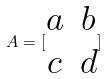Convert formula to latex. <formula><loc_0><loc_0><loc_500><loc_500>A = [ \begin{matrix} a & b \\ c & d \end{matrix} ]</formula> 